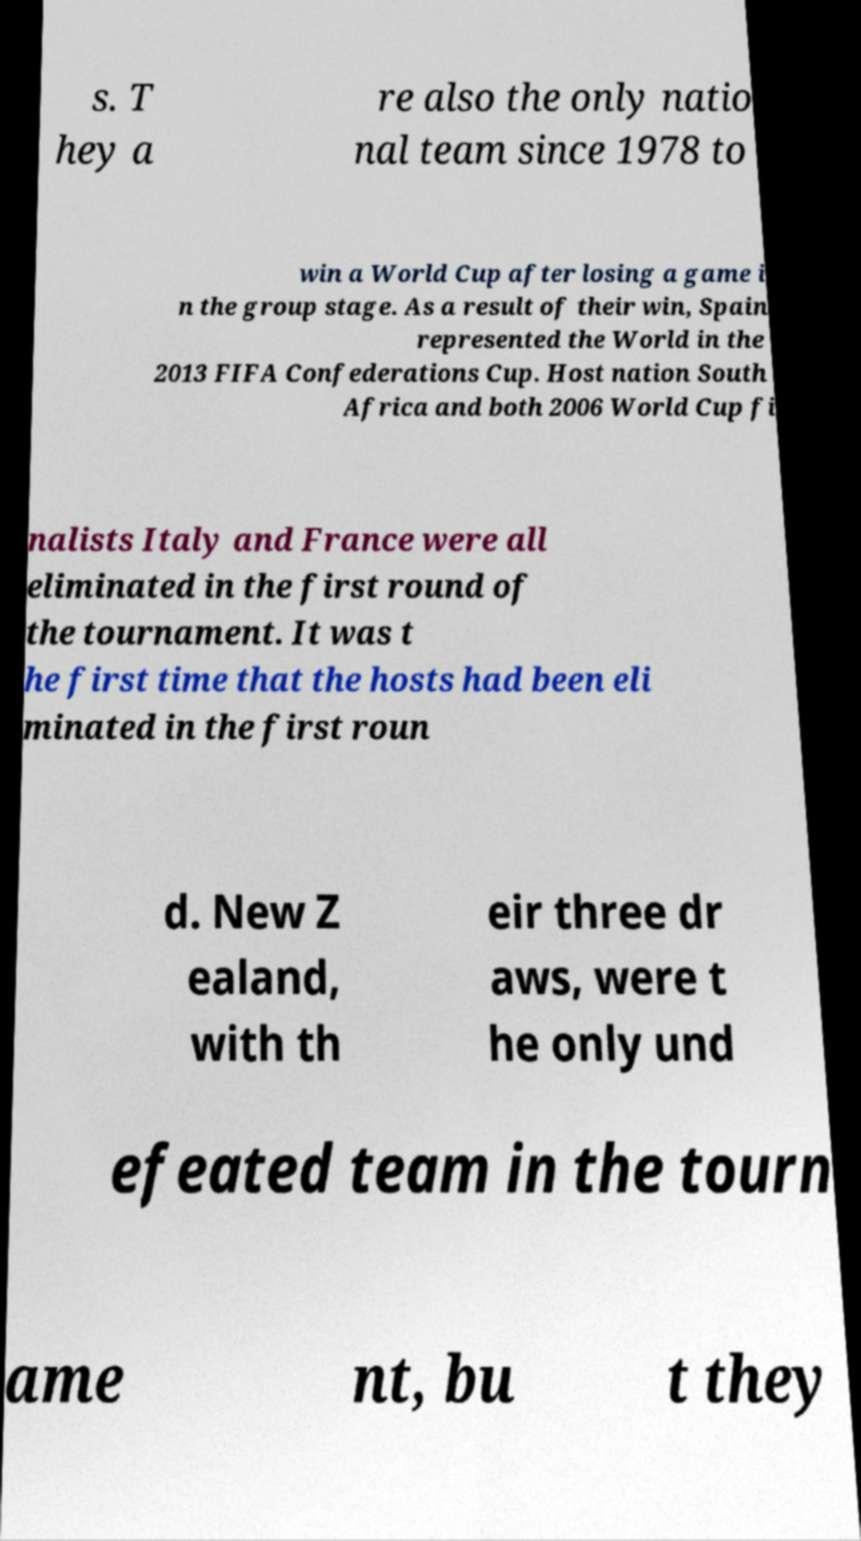Can you read and provide the text displayed in the image?This photo seems to have some interesting text. Can you extract and type it out for me? s. T hey a re also the only natio nal team since 1978 to win a World Cup after losing a game i n the group stage. As a result of their win, Spain represented the World in the 2013 FIFA Confederations Cup. Host nation South Africa and both 2006 World Cup fi nalists Italy and France were all eliminated in the first round of the tournament. It was t he first time that the hosts had been eli minated in the first roun d. New Z ealand, with th eir three dr aws, were t he only und efeated team in the tourn ame nt, bu t they 